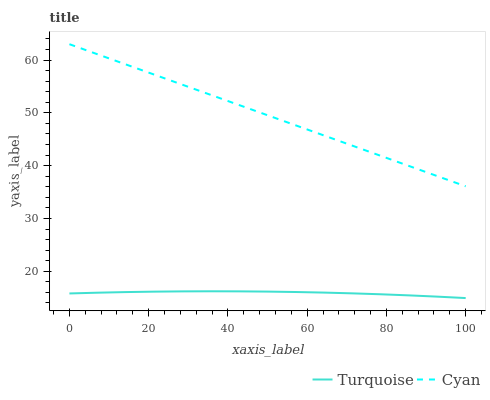Does Turquoise have the minimum area under the curve?
Answer yes or no. Yes. Does Cyan have the maximum area under the curve?
Answer yes or no. Yes. Does Turquoise have the maximum area under the curve?
Answer yes or no. No. Is Cyan the smoothest?
Answer yes or no. Yes. Is Turquoise the roughest?
Answer yes or no. Yes. Is Turquoise the smoothest?
Answer yes or no. No. Does Cyan have the highest value?
Answer yes or no. Yes. Does Turquoise have the highest value?
Answer yes or no. No. Is Turquoise less than Cyan?
Answer yes or no. Yes. Is Cyan greater than Turquoise?
Answer yes or no. Yes. Does Turquoise intersect Cyan?
Answer yes or no. No. 